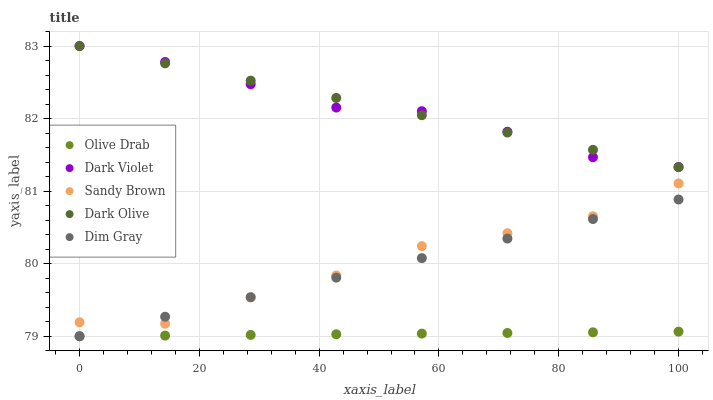Does Olive Drab have the minimum area under the curve?
Answer yes or no. Yes. Does Dark Olive have the maximum area under the curve?
Answer yes or no. Yes. Does Sandy Brown have the minimum area under the curve?
Answer yes or no. No. Does Sandy Brown have the maximum area under the curve?
Answer yes or no. No. Is Dark Olive the smoothest?
Answer yes or no. Yes. Is Sandy Brown the roughest?
Answer yes or no. Yes. Is Sandy Brown the smoothest?
Answer yes or no. No. Is Dark Olive the roughest?
Answer yes or no. No. Does Dim Gray have the lowest value?
Answer yes or no. Yes. Does Dark Olive have the lowest value?
Answer yes or no. No. Does Dark Violet have the highest value?
Answer yes or no. Yes. Does Sandy Brown have the highest value?
Answer yes or no. No. Is Olive Drab less than Dark Violet?
Answer yes or no. Yes. Is Dark Violet greater than Dim Gray?
Answer yes or no. Yes. Does Dim Gray intersect Olive Drab?
Answer yes or no. Yes. Is Dim Gray less than Olive Drab?
Answer yes or no. No. Is Dim Gray greater than Olive Drab?
Answer yes or no. No. Does Olive Drab intersect Dark Violet?
Answer yes or no. No. 